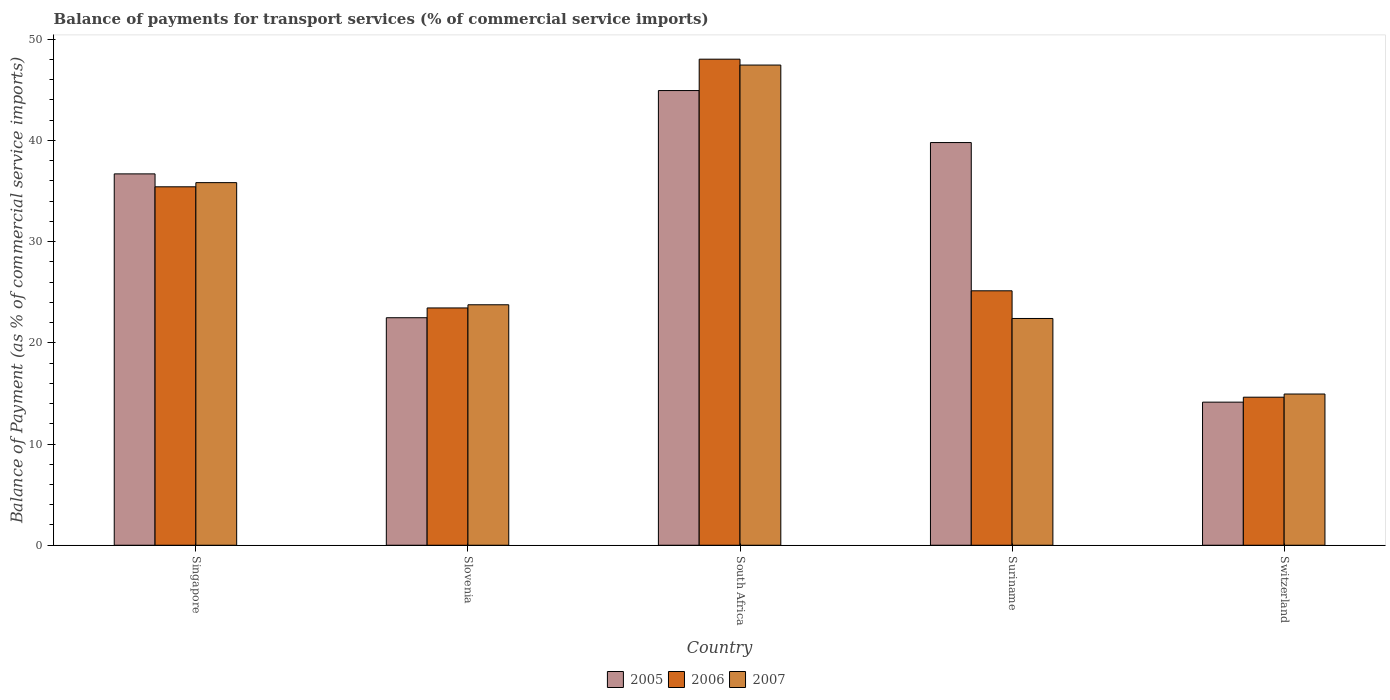Are the number of bars on each tick of the X-axis equal?
Offer a terse response. Yes. How many bars are there on the 4th tick from the right?
Provide a succinct answer. 3. What is the label of the 1st group of bars from the left?
Your answer should be very brief. Singapore. What is the balance of payments for transport services in 2005 in South Africa?
Give a very brief answer. 44.93. Across all countries, what is the maximum balance of payments for transport services in 2007?
Keep it short and to the point. 47.45. Across all countries, what is the minimum balance of payments for transport services in 2005?
Ensure brevity in your answer.  14.14. In which country was the balance of payments for transport services in 2005 maximum?
Offer a terse response. South Africa. In which country was the balance of payments for transport services in 2006 minimum?
Provide a short and direct response. Switzerland. What is the total balance of payments for transport services in 2005 in the graph?
Keep it short and to the point. 158.03. What is the difference between the balance of payments for transport services in 2007 in South Africa and that in Suriname?
Offer a terse response. 25.04. What is the difference between the balance of payments for transport services in 2007 in Slovenia and the balance of payments for transport services in 2005 in Singapore?
Your response must be concise. -12.93. What is the average balance of payments for transport services in 2006 per country?
Your response must be concise. 29.33. What is the difference between the balance of payments for transport services of/in 2005 and balance of payments for transport services of/in 2007 in Switzerland?
Keep it short and to the point. -0.8. What is the ratio of the balance of payments for transport services in 2007 in Singapore to that in Suriname?
Provide a short and direct response. 1.6. Is the balance of payments for transport services in 2005 in Singapore less than that in South Africa?
Ensure brevity in your answer.  Yes. What is the difference between the highest and the second highest balance of payments for transport services in 2005?
Make the answer very short. 8.23. What is the difference between the highest and the lowest balance of payments for transport services in 2007?
Give a very brief answer. 32.51. What does the 2nd bar from the left in Suriname represents?
Your answer should be very brief. 2006. What does the 1st bar from the right in South Africa represents?
Make the answer very short. 2007. Is it the case that in every country, the sum of the balance of payments for transport services in 2005 and balance of payments for transport services in 2007 is greater than the balance of payments for transport services in 2006?
Make the answer very short. Yes. How many bars are there?
Give a very brief answer. 15. Are all the bars in the graph horizontal?
Provide a short and direct response. No. What is the difference between two consecutive major ticks on the Y-axis?
Ensure brevity in your answer.  10. Where does the legend appear in the graph?
Your response must be concise. Bottom center. How many legend labels are there?
Give a very brief answer. 3. How are the legend labels stacked?
Your answer should be very brief. Horizontal. What is the title of the graph?
Ensure brevity in your answer.  Balance of payments for transport services (% of commercial service imports). What is the label or title of the X-axis?
Keep it short and to the point. Country. What is the label or title of the Y-axis?
Provide a short and direct response. Balance of Payment (as % of commercial service imports). What is the Balance of Payment (as % of commercial service imports) of 2005 in Singapore?
Offer a very short reply. 36.69. What is the Balance of Payment (as % of commercial service imports) in 2006 in Singapore?
Your answer should be compact. 35.42. What is the Balance of Payment (as % of commercial service imports) of 2007 in Singapore?
Offer a terse response. 35.83. What is the Balance of Payment (as % of commercial service imports) of 2005 in Slovenia?
Keep it short and to the point. 22.48. What is the Balance of Payment (as % of commercial service imports) in 2006 in Slovenia?
Your response must be concise. 23.45. What is the Balance of Payment (as % of commercial service imports) of 2007 in Slovenia?
Give a very brief answer. 23.76. What is the Balance of Payment (as % of commercial service imports) in 2005 in South Africa?
Provide a short and direct response. 44.93. What is the Balance of Payment (as % of commercial service imports) of 2006 in South Africa?
Your response must be concise. 48.03. What is the Balance of Payment (as % of commercial service imports) of 2007 in South Africa?
Offer a very short reply. 47.45. What is the Balance of Payment (as % of commercial service imports) in 2005 in Suriname?
Keep it short and to the point. 39.79. What is the Balance of Payment (as % of commercial service imports) in 2006 in Suriname?
Give a very brief answer. 25.14. What is the Balance of Payment (as % of commercial service imports) in 2007 in Suriname?
Make the answer very short. 22.41. What is the Balance of Payment (as % of commercial service imports) in 2005 in Switzerland?
Provide a short and direct response. 14.14. What is the Balance of Payment (as % of commercial service imports) in 2006 in Switzerland?
Keep it short and to the point. 14.63. What is the Balance of Payment (as % of commercial service imports) in 2007 in Switzerland?
Your response must be concise. 14.94. Across all countries, what is the maximum Balance of Payment (as % of commercial service imports) in 2005?
Offer a terse response. 44.93. Across all countries, what is the maximum Balance of Payment (as % of commercial service imports) in 2006?
Make the answer very short. 48.03. Across all countries, what is the maximum Balance of Payment (as % of commercial service imports) in 2007?
Give a very brief answer. 47.45. Across all countries, what is the minimum Balance of Payment (as % of commercial service imports) of 2005?
Your answer should be very brief. 14.14. Across all countries, what is the minimum Balance of Payment (as % of commercial service imports) of 2006?
Offer a very short reply. 14.63. Across all countries, what is the minimum Balance of Payment (as % of commercial service imports) of 2007?
Provide a short and direct response. 14.94. What is the total Balance of Payment (as % of commercial service imports) of 2005 in the graph?
Offer a very short reply. 158.03. What is the total Balance of Payment (as % of commercial service imports) of 2006 in the graph?
Provide a succinct answer. 146.66. What is the total Balance of Payment (as % of commercial service imports) in 2007 in the graph?
Offer a very short reply. 144.39. What is the difference between the Balance of Payment (as % of commercial service imports) of 2005 in Singapore and that in Slovenia?
Provide a succinct answer. 14.21. What is the difference between the Balance of Payment (as % of commercial service imports) in 2006 in Singapore and that in Slovenia?
Offer a very short reply. 11.97. What is the difference between the Balance of Payment (as % of commercial service imports) in 2007 in Singapore and that in Slovenia?
Your answer should be compact. 12.07. What is the difference between the Balance of Payment (as % of commercial service imports) of 2005 in Singapore and that in South Africa?
Keep it short and to the point. -8.23. What is the difference between the Balance of Payment (as % of commercial service imports) of 2006 in Singapore and that in South Africa?
Your response must be concise. -12.61. What is the difference between the Balance of Payment (as % of commercial service imports) in 2007 in Singapore and that in South Africa?
Make the answer very short. -11.62. What is the difference between the Balance of Payment (as % of commercial service imports) of 2005 in Singapore and that in Suriname?
Make the answer very short. -3.1. What is the difference between the Balance of Payment (as % of commercial service imports) in 2006 in Singapore and that in Suriname?
Give a very brief answer. 10.28. What is the difference between the Balance of Payment (as % of commercial service imports) in 2007 in Singapore and that in Suriname?
Make the answer very short. 13.42. What is the difference between the Balance of Payment (as % of commercial service imports) of 2005 in Singapore and that in Switzerland?
Make the answer very short. 22.56. What is the difference between the Balance of Payment (as % of commercial service imports) in 2006 in Singapore and that in Switzerland?
Ensure brevity in your answer.  20.79. What is the difference between the Balance of Payment (as % of commercial service imports) of 2007 in Singapore and that in Switzerland?
Make the answer very short. 20.89. What is the difference between the Balance of Payment (as % of commercial service imports) in 2005 in Slovenia and that in South Africa?
Ensure brevity in your answer.  -22.45. What is the difference between the Balance of Payment (as % of commercial service imports) in 2006 in Slovenia and that in South Africa?
Give a very brief answer. -24.58. What is the difference between the Balance of Payment (as % of commercial service imports) in 2007 in Slovenia and that in South Africa?
Offer a very short reply. -23.69. What is the difference between the Balance of Payment (as % of commercial service imports) in 2005 in Slovenia and that in Suriname?
Provide a succinct answer. -17.31. What is the difference between the Balance of Payment (as % of commercial service imports) in 2006 in Slovenia and that in Suriname?
Provide a short and direct response. -1.69. What is the difference between the Balance of Payment (as % of commercial service imports) in 2007 in Slovenia and that in Suriname?
Your response must be concise. 1.35. What is the difference between the Balance of Payment (as % of commercial service imports) of 2005 in Slovenia and that in Switzerland?
Your response must be concise. 8.34. What is the difference between the Balance of Payment (as % of commercial service imports) of 2006 in Slovenia and that in Switzerland?
Your answer should be compact. 8.82. What is the difference between the Balance of Payment (as % of commercial service imports) of 2007 in Slovenia and that in Switzerland?
Keep it short and to the point. 8.82. What is the difference between the Balance of Payment (as % of commercial service imports) of 2005 in South Africa and that in Suriname?
Ensure brevity in your answer.  5.14. What is the difference between the Balance of Payment (as % of commercial service imports) of 2006 in South Africa and that in Suriname?
Ensure brevity in your answer.  22.89. What is the difference between the Balance of Payment (as % of commercial service imports) of 2007 in South Africa and that in Suriname?
Provide a succinct answer. 25.04. What is the difference between the Balance of Payment (as % of commercial service imports) in 2005 in South Africa and that in Switzerland?
Your response must be concise. 30.79. What is the difference between the Balance of Payment (as % of commercial service imports) of 2006 in South Africa and that in Switzerland?
Provide a short and direct response. 33.4. What is the difference between the Balance of Payment (as % of commercial service imports) in 2007 in South Africa and that in Switzerland?
Your answer should be very brief. 32.51. What is the difference between the Balance of Payment (as % of commercial service imports) in 2005 in Suriname and that in Switzerland?
Give a very brief answer. 25.65. What is the difference between the Balance of Payment (as % of commercial service imports) of 2006 in Suriname and that in Switzerland?
Provide a short and direct response. 10.51. What is the difference between the Balance of Payment (as % of commercial service imports) of 2007 in Suriname and that in Switzerland?
Offer a terse response. 7.46. What is the difference between the Balance of Payment (as % of commercial service imports) of 2005 in Singapore and the Balance of Payment (as % of commercial service imports) of 2006 in Slovenia?
Offer a very short reply. 13.25. What is the difference between the Balance of Payment (as % of commercial service imports) of 2005 in Singapore and the Balance of Payment (as % of commercial service imports) of 2007 in Slovenia?
Your response must be concise. 12.93. What is the difference between the Balance of Payment (as % of commercial service imports) in 2006 in Singapore and the Balance of Payment (as % of commercial service imports) in 2007 in Slovenia?
Provide a short and direct response. 11.66. What is the difference between the Balance of Payment (as % of commercial service imports) of 2005 in Singapore and the Balance of Payment (as % of commercial service imports) of 2006 in South Africa?
Keep it short and to the point. -11.34. What is the difference between the Balance of Payment (as % of commercial service imports) in 2005 in Singapore and the Balance of Payment (as % of commercial service imports) in 2007 in South Africa?
Your answer should be compact. -10.75. What is the difference between the Balance of Payment (as % of commercial service imports) of 2006 in Singapore and the Balance of Payment (as % of commercial service imports) of 2007 in South Africa?
Offer a terse response. -12.03. What is the difference between the Balance of Payment (as % of commercial service imports) of 2005 in Singapore and the Balance of Payment (as % of commercial service imports) of 2006 in Suriname?
Your response must be concise. 11.55. What is the difference between the Balance of Payment (as % of commercial service imports) in 2005 in Singapore and the Balance of Payment (as % of commercial service imports) in 2007 in Suriname?
Make the answer very short. 14.29. What is the difference between the Balance of Payment (as % of commercial service imports) of 2006 in Singapore and the Balance of Payment (as % of commercial service imports) of 2007 in Suriname?
Your answer should be very brief. 13.01. What is the difference between the Balance of Payment (as % of commercial service imports) in 2005 in Singapore and the Balance of Payment (as % of commercial service imports) in 2006 in Switzerland?
Provide a short and direct response. 22.07. What is the difference between the Balance of Payment (as % of commercial service imports) in 2005 in Singapore and the Balance of Payment (as % of commercial service imports) in 2007 in Switzerland?
Offer a terse response. 21.75. What is the difference between the Balance of Payment (as % of commercial service imports) of 2006 in Singapore and the Balance of Payment (as % of commercial service imports) of 2007 in Switzerland?
Provide a succinct answer. 20.48. What is the difference between the Balance of Payment (as % of commercial service imports) of 2005 in Slovenia and the Balance of Payment (as % of commercial service imports) of 2006 in South Africa?
Your answer should be compact. -25.55. What is the difference between the Balance of Payment (as % of commercial service imports) of 2005 in Slovenia and the Balance of Payment (as % of commercial service imports) of 2007 in South Africa?
Give a very brief answer. -24.97. What is the difference between the Balance of Payment (as % of commercial service imports) of 2006 in Slovenia and the Balance of Payment (as % of commercial service imports) of 2007 in South Africa?
Make the answer very short. -24. What is the difference between the Balance of Payment (as % of commercial service imports) in 2005 in Slovenia and the Balance of Payment (as % of commercial service imports) in 2006 in Suriname?
Offer a very short reply. -2.66. What is the difference between the Balance of Payment (as % of commercial service imports) of 2005 in Slovenia and the Balance of Payment (as % of commercial service imports) of 2007 in Suriname?
Offer a very short reply. 0.07. What is the difference between the Balance of Payment (as % of commercial service imports) in 2006 in Slovenia and the Balance of Payment (as % of commercial service imports) in 2007 in Suriname?
Keep it short and to the point. 1.04. What is the difference between the Balance of Payment (as % of commercial service imports) in 2005 in Slovenia and the Balance of Payment (as % of commercial service imports) in 2006 in Switzerland?
Make the answer very short. 7.85. What is the difference between the Balance of Payment (as % of commercial service imports) of 2005 in Slovenia and the Balance of Payment (as % of commercial service imports) of 2007 in Switzerland?
Your answer should be compact. 7.54. What is the difference between the Balance of Payment (as % of commercial service imports) of 2006 in Slovenia and the Balance of Payment (as % of commercial service imports) of 2007 in Switzerland?
Give a very brief answer. 8.51. What is the difference between the Balance of Payment (as % of commercial service imports) of 2005 in South Africa and the Balance of Payment (as % of commercial service imports) of 2006 in Suriname?
Your answer should be very brief. 19.79. What is the difference between the Balance of Payment (as % of commercial service imports) in 2005 in South Africa and the Balance of Payment (as % of commercial service imports) in 2007 in Suriname?
Your answer should be very brief. 22.52. What is the difference between the Balance of Payment (as % of commercial service imports) of 2006 in South Africa and the Balance of Payment (as % of commercial service imports) of 2007 in Suriname?
Offer a terse response. 25.62. What is the difference between the Balance of Payment (as % of commercial service imports) of 2005 in South Africa and the Balance of Payment (as % of commercial service imports) of 2006 in Switzerland?
Your answer should be very brief. 30.3. What is the difference between the Balance of Payment (as % of commercial service imports) of 2005 in South Africa and the Balance of Payment (as % of commercial service imports) of 2007 in Switzerland?
Your response must be concise. 29.99. What is the difference between the Balance of Payment (as % of commercial service imports) in 2006 in South Africa and the Balance of Payment (as % of commercial service imports) in 2007 in Switzerland?
Give a very brief answer. 33.09. What is the difference between the Balance of Payment (as % of commercial service imports) in 2005 in Suriname and the Balance of Payment (as % of commercial service imports) in 2006 in Switzerland?
Offer a terse response. 25.16. What is the difference between the Balance of Payment (as % of commercial service imports) in 2005 in Suriname and the Balance of Payment (as % of commercial service imports) in 2007 in Switzerland?
Make the answer very short. 24.85. What is the difference between the Balance of Payment (as % of commercial service imports) in 2006 in Suriname and the Balance of Payment (as % of commercial service imports) in 2007 in Switzerland?
Offer a very short reply. 10.2. What is the average Balance of Payment (as % of commercial service imports) of 2005 per country?
Your answer should be very brief. 31.61. What is the average Balance of Payment (as % of commercial service imports) of 2006 per country?
Ensure brevity in your answer.  29.33. What is the average Balance of Payment (as % of commercial service imports) in 2007 per country?
Ensure brevity in your answer.  28.88. What is the difference between the Balance of Payment (as % of commercial service imports) in 2005 and Balance of Payment (as % of commercial service imports) in 2006 in Singapore?
Your answer should be compact. 1.28. What is the difference between the Balance of Payment (as % of commercial service imports) in 2005 and Balance of Payment (as % of commercial service imports) in 2007 in Singapore?
Make the answer very short. 0.86. What is the difference between the Balance of Payment (as % of commercial service imports) in 2006 and Balance of Payment (as % of commercial service imports) in 2007 in Singapore?
Your answer should be compact. -0.41. What is the difference between the Balance of Payment (as % of commercial service imports) in 2005 and Balance of Payment (as % of commercial service imports) in 2006 in Slovenia?
Your answer should be compact. -0.97. What is the difference between the Balance of Payment (as % of commercial service imports) of 2005 and Balance of Payment (as % of commercial service imports) of 2007 in Slovenia?
Give a very brief answer. -1.28. What is the difference between the Balance of Payment (as % of commercial service imports) in 2006 and Balance of Payment (as % of commercial service imports) in 2007 in Slovenia?
Offer a very short reply. -0.31. What is the difference between the Balance of Payment (as % of commercial service imports) in 2005 and Balance of Payment (as % of commercial service imports) in 2006 in South Africa?
Your answer should be very brief. -3.1. What is the difference between the Balance of Payment (as % of commercial service imports) of 2005 and Balance of Payment (as % of commercial service imports) of 2007 in South Africa?
Your answer should be compact. -2.52. What is the difference between the Balance of Payment (as % of commercial service imports) of 2006 and Balance of Payment (as % of commercial service imports) of 2007 in South Africa?
Offer a terse response. 0.58. What is the difference between the Balance of Payment (as % of commercial service imports) of 2005 and Balance of Payment (as % of commercial service imports) of 2006 in Suriname?
Give a very brief answer. 14.65. What is the difference between the Balance of Payment (as % of commercial service imports) in 2005 and Balance of Payment (as % of commercial service imports) in 2007 in Suriname?
Your answer should be very brief. 17.38. What is the difference between the Balance of Payment (as % of commercial service imports) of 2006 and Balance of Payment (as % of commercial service imports) of 2007 in Suriname?
Keep it short and to the point. 2.73. What is the difference between the Balance of Payment (as % of commercial service imports) of 2005 and Balance of Payment (as % of commercial service imports) of 2006 in Switzerland?
Your answer should be compact. -0.49. What is the difference between the Balance of Payment (as % of commercial service imports) of 2005 and Balance of Payment (as % of commercial service imports) of 2007 in Switzerland?
Provide a succinct answer. -0.8. What is the difference between the Balance of Payment (as % of commercial service imports) of 2006 and Balance of Payment (as % of commercial service imports) of 2007 in Switzerland?
Ensure brevity in your answer.  -0.31. What is the ratio of the Balance of Payment (as % of commercial service imports) in 2005 in Singapore to that in Slovenia?
Your answer should be compact. 1.63. What is the ratio of the Balance of Payment (as % of commercial service imports) of 2006 in Singapore to that in Slovenia?
Your answer should be compact. 1.51. What is the ratio of the Balance of Payment (as % of commercial service imports) in 2007 in Singapore to that in Slovenia?
Make the answer very short. 1.51. What is the ratio of the Balance of Payment (as % of commercial service imports) in 2005 in Singapore to that in South Africa?
Your answer should be very brief. 0.82. What is the ratio of the Balance of Payment (as % of commercial service imports) of 2006 in Singapore to that in South Africa?
Your response must be concise. 0.74. What is the ratio of the Balance of Payment (as % of commercial service imports) of 2007 in Singapore to that in South Africa?
Provide a succinct answer. 0.76. What is the ratio of the Balance of Payment (as % of commercial service imports) of 2005 in Singapore to that in Suriname?
Your response must be concise. 0.92. What is the ratio of the Balance of Payment (as % of commercial service imports) in 2006 in Singapore to that in Suriname?
Ensure brevity in your answer.  1.41. What is the ratio of the Balance of Payment (as % of commercial service imports) of 2007 in Singapore to that in Suriname?
Give a very brief answer. 1.6. What is the ratio of the Balance of Payment (as % of commercial service imports) of 2005 in Singapore to that in Switzerland?
Your answer should be compact. 2.6. What is the ratio of the Balance of Payment (as % of commercial service imports) in 2006 in Singapore to that in Switzerland?
Give a very brief answer. 2.42. What is the ratio of the Balance of Payment (as % of commercial service imports) in 2007 in Singapore to that in Switzerland?
Keep it short and to the point. 2.4. What is the ratio of the Balance of Payment (as % of commercial service imports) in 2005 in Slovenia to that in South Africa?
Ensure brevity in your answer.  0.5. What is the ratio of the Balance of Payment (as % of commercial service imports) of 2006 in Slovenia to that in South Africa?
Provide a succinct answer. 0.49. What is the ratio of the Balance of Payment (as % of commercial service imports) in 2007 in Slovenia to that in South Africa?
Your answer should be compact. 0.5. What is the ratio of the Balance of Payment (as % of commercial service imports) in 2005 in Slovenia to that in Suriname?
Your response must be concise. 0.56. What is the ratio of the Balance of Payment (as % of commercial service imports) in 2006 in Slovenia to that in Suriname?
Give a very brief answer. 0.93. What is the ratio of the Balance of Payment (as % of commercial service imports) of 2007 in Slovenia to that in Suriname?
Keep it short and to the point. 1.06. What is the ratio of the Balance of Payment (as % of commercial service imports) in 2005 in Slovenia to that in Switzerland?
Provide a succinct answer. 1.59. What is the ratio of the Balance of Payment (as % of commercial service imports) in 2006 in Slovenia to that in Switzerland?
Make the answer very short. 1.6. What is the ratio of the Balance of Payment (as % of commercial service imports) of 2007 in Slovenia to that in Switzerland?
Your answer should be compact. 1.59. What is the ratio of the Balance of Payment (as % of commercial service imports) in 2005 in South Africa to that in Suriname?
Provide a short and direct response. 1.13. What is the ratio of the Balance of Payment (as % of commercial service imports) of 2006 in South Africa to that in Suriname?
Provide a succinct answer. 1.91. What is the ratio of the Balance of Payment (as % of commercial service imports) of 2007 in South Africa to that in Suriname?
Keep it short and to the point. 2.12. What is the ratio of the Balance of Payment (as % of commercial service imports) in 2005 in South Africa to that in Switzerland?
Ensure brevity in your answer.  3.18. What is the ratio of the Balance of Payment (as % of commercial service imports) in 2006 in South Africa to that in Switzerland?
Give a very brief answer. 3.28. What is the ratio of the Balance of Payment (as % of commercial service imports) of 2007 in South Africa to that in Switzerland?
Give a very brief answer. 3.18. What is the ratio of the Balance of Payment (as % of commercial service imports) in 2005 in Suriname to that in Switzerland?
Your response must be concise. 2.81. What is the ratio of the Balance of Payment (as % of commercial service imports) of 2006 in Suriname to that in Switzerland?
Keep it short and to the point. 1.72. What is the ratio of the Balance of Payment (as % of commercial service imports) of 2007 in Suriname to that in Switzerland?
Give a very brief answer. 1.5. What is the difference between the highest and the second highest Balance of Payment (as % of commercial service imports) of 2005?
Ensure brevity in your answer.  5.14. What is the difference between the highest and the second highest Balance of Payment (as % of commercial service imports) of 2006?
Your answer should be compact. 12.61. What is the difference between the highest and the second highest Balance of Payment (as % of commercial service imports) in 2007?
Offer a very short reply. 11.62. What is the difference between the highest and the lowest Balance of Payment (as % of commercial service imports) in 2005?
Your answer should be very brief. 30.79. What is the difference between the highest and the lowest Balance of Payment (as % of commercial service imports) of 2006?
Make the answer very short. 33.4. What is the difference between the highest and the lowest Balance of Payment (as % of commercial service imports) in 2007?
Your answer should be very brief. 32.51. 